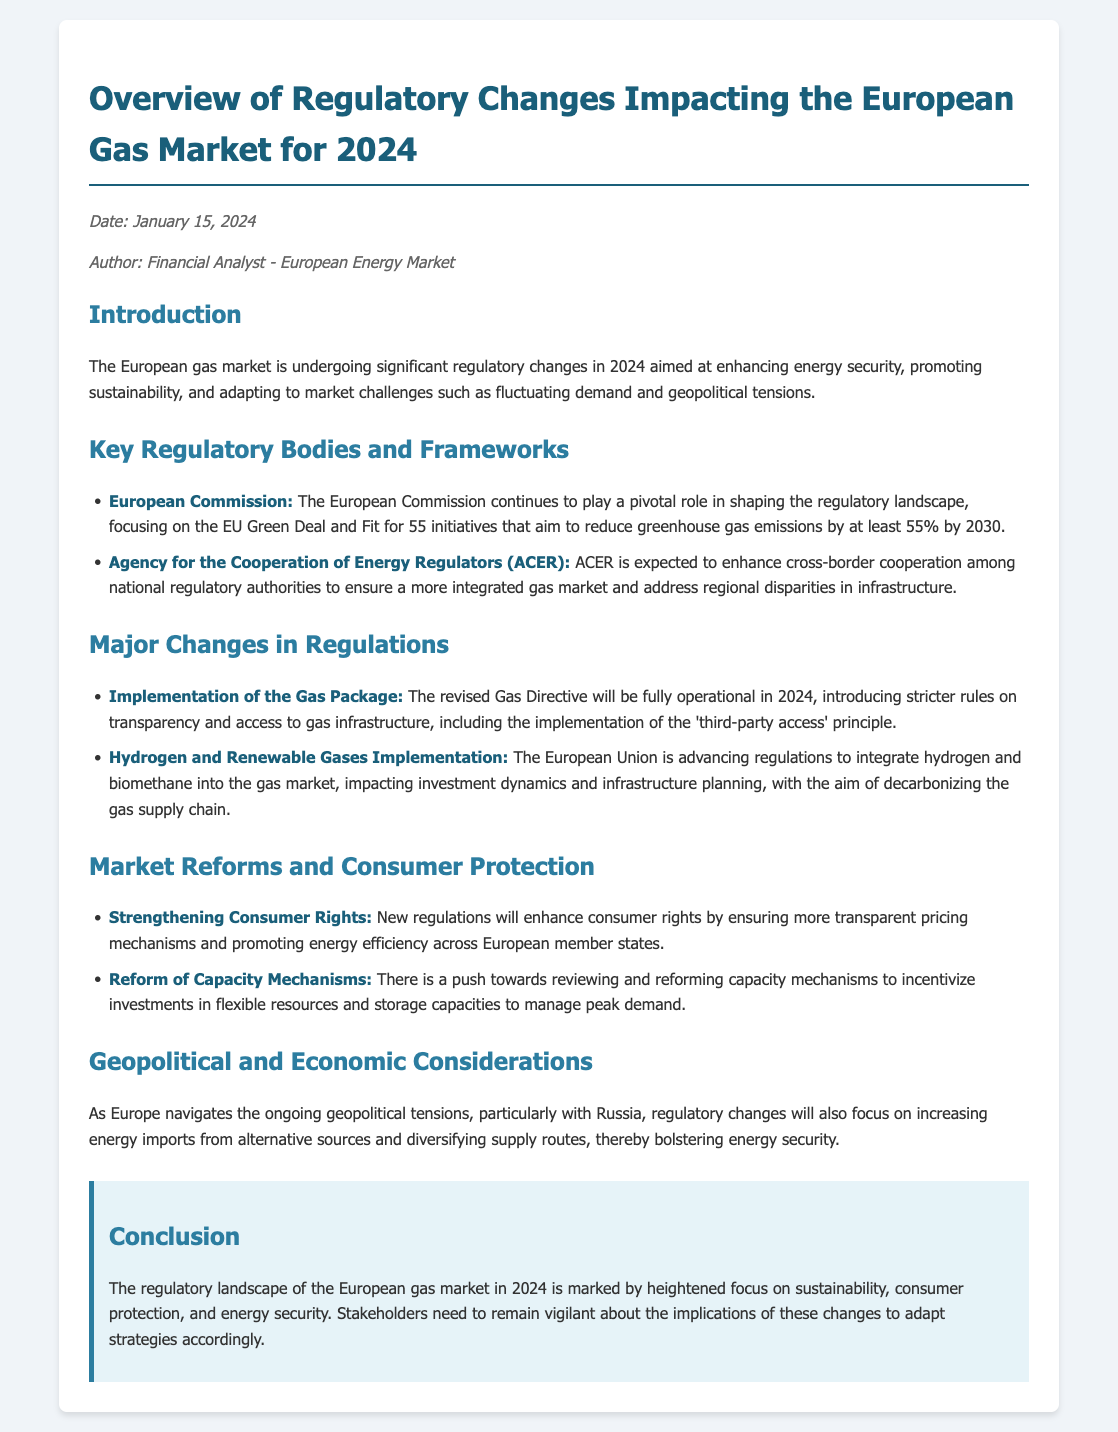What is the date of the memo? The date is specified in the meta section of the document.
Answer: January 15, 2024 Who authored the memo? The author information is included in the meta section of the document.
Answer: Financial Analyst - European Energy Market What is the primary focus of the European Commission's regulations? The focus is mentioned in the key regulatory bodies section of the document.
Answer: EU Green Deal and Fit for 55 initiatives What is the new implementation regarding transparency? The implementation is detailed in the major changes section of the document.
Answer: 'third-party access' principle Which gases are being integrated into the gas market? The gases are specified under the major changes section of the document.
Answer: hydrogen and biomethane What new consumer protection measure is introduced? The measure is outlined in the market reforms section of the document.
Answer: Strengthening Consumer Rights What is a key goal concerning energy sources in the geopolitical context? The goal is discussed in the geopolitical and economic considerations section of the document.
Answer: Increasing energy imports from alternative sources What does the conclusion emphasize about the regulatory landscape? The conclusion summarizes the overall themes mentioned in the document.
Answer: Heightened focus on sustainability, consumer protection, and energy security 